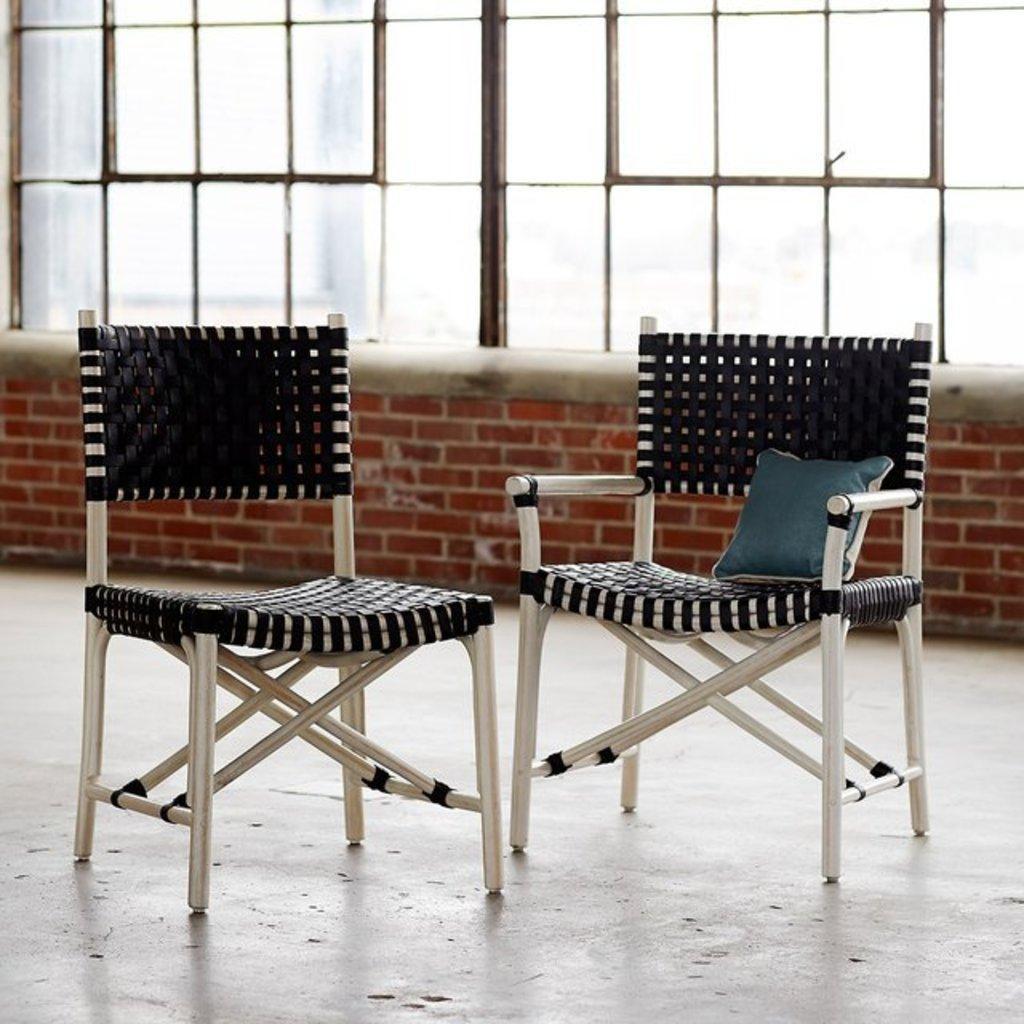How would you summarize this image in a sentence or two? In this picture we can see two chairs on the ground, here we can see a pillow and in the background we can see the wall and windows. 